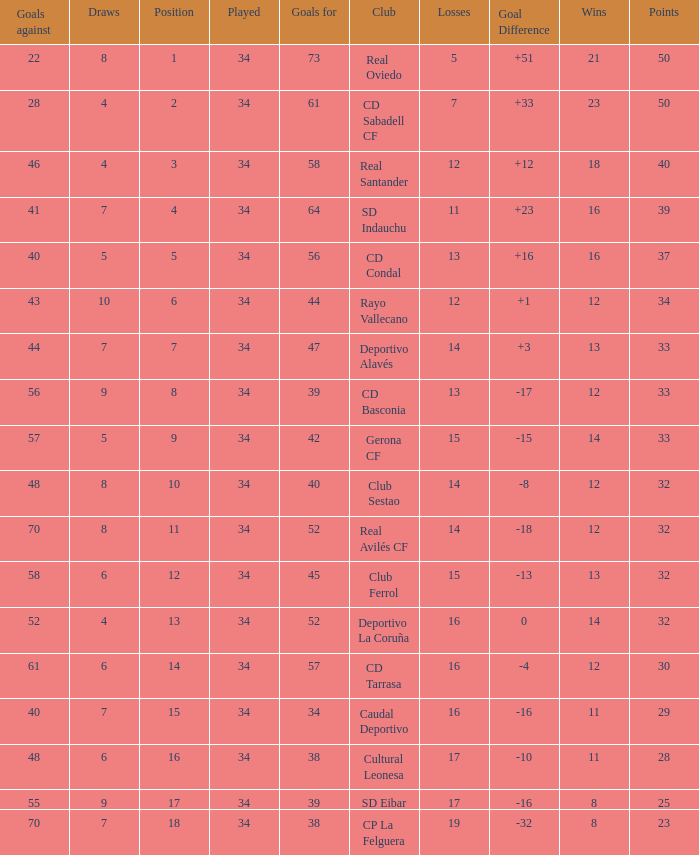Which Played has Draws smaller than 7, and Goals for smaller than 61, and Goals against smaller than 48, and a Position of 5? 34.0. 